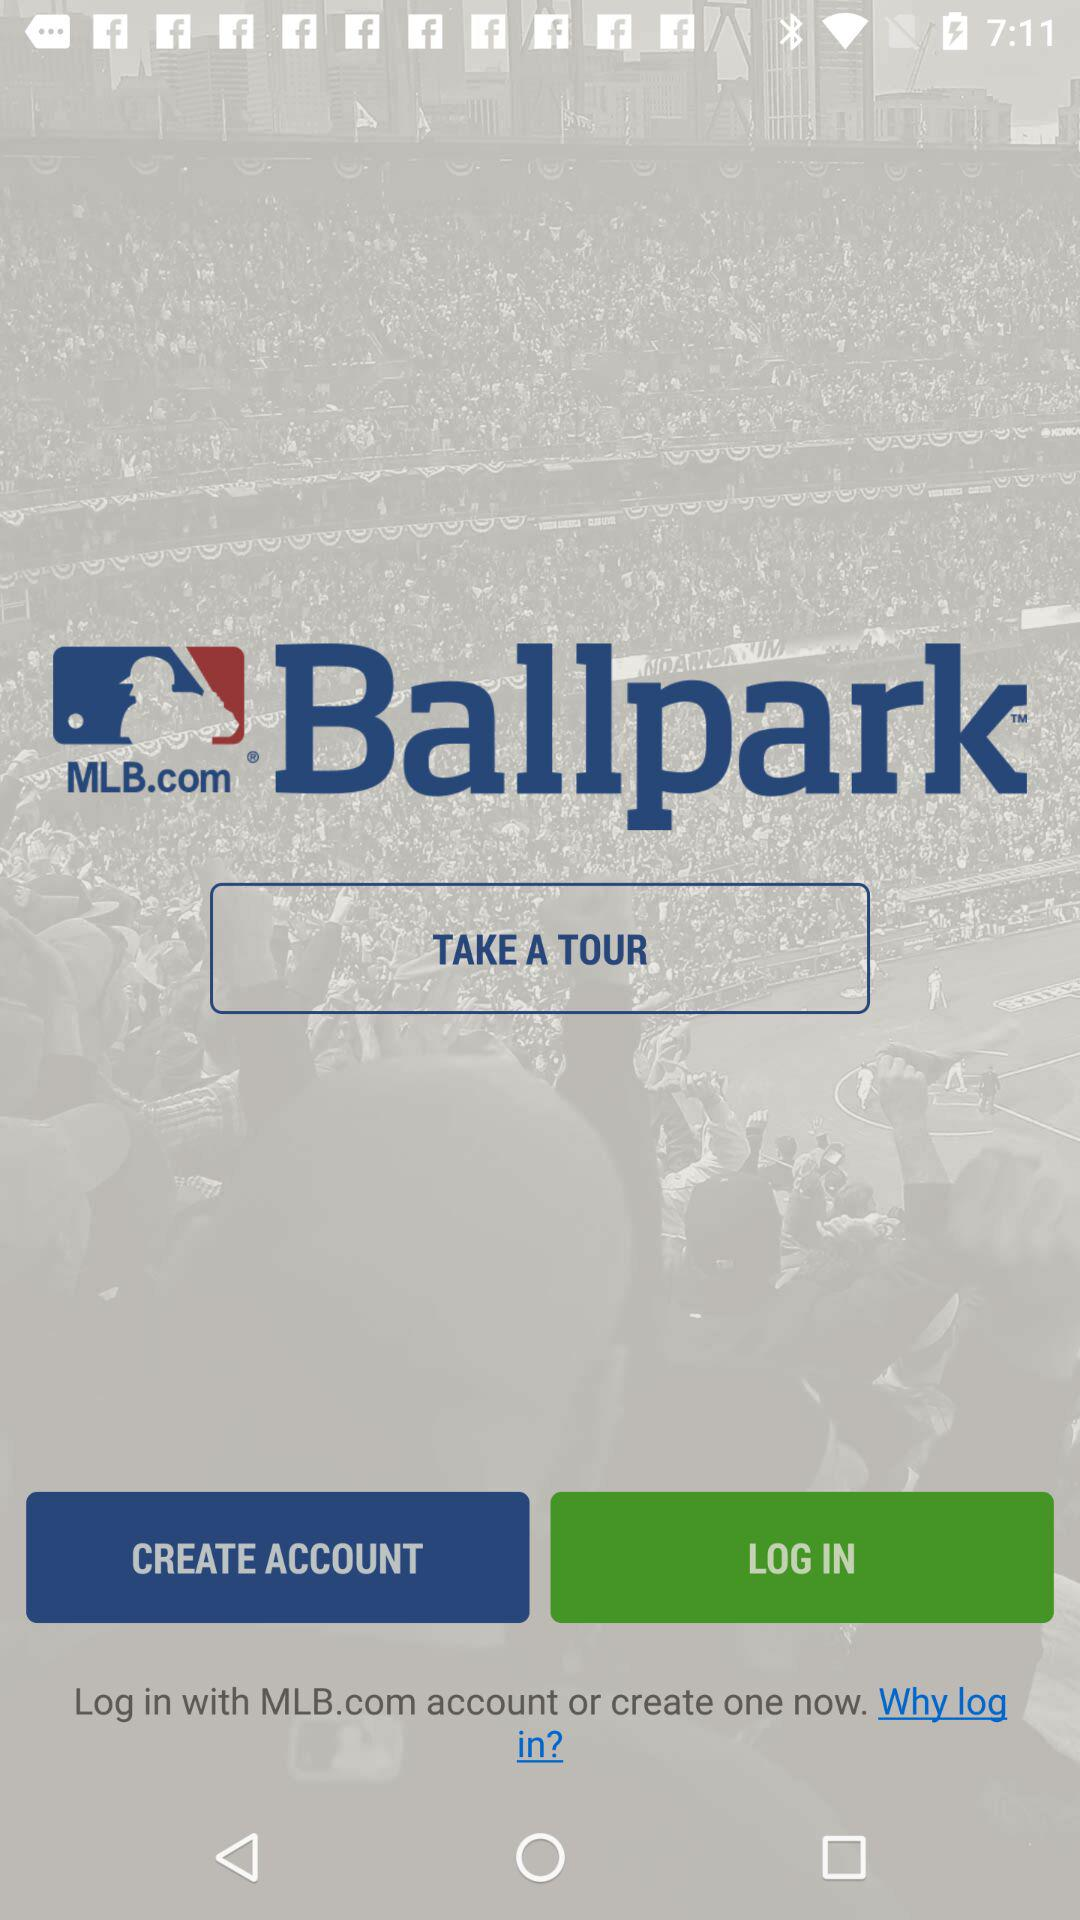What is the name of the application? The name of the application is "MLB Ballpark". 